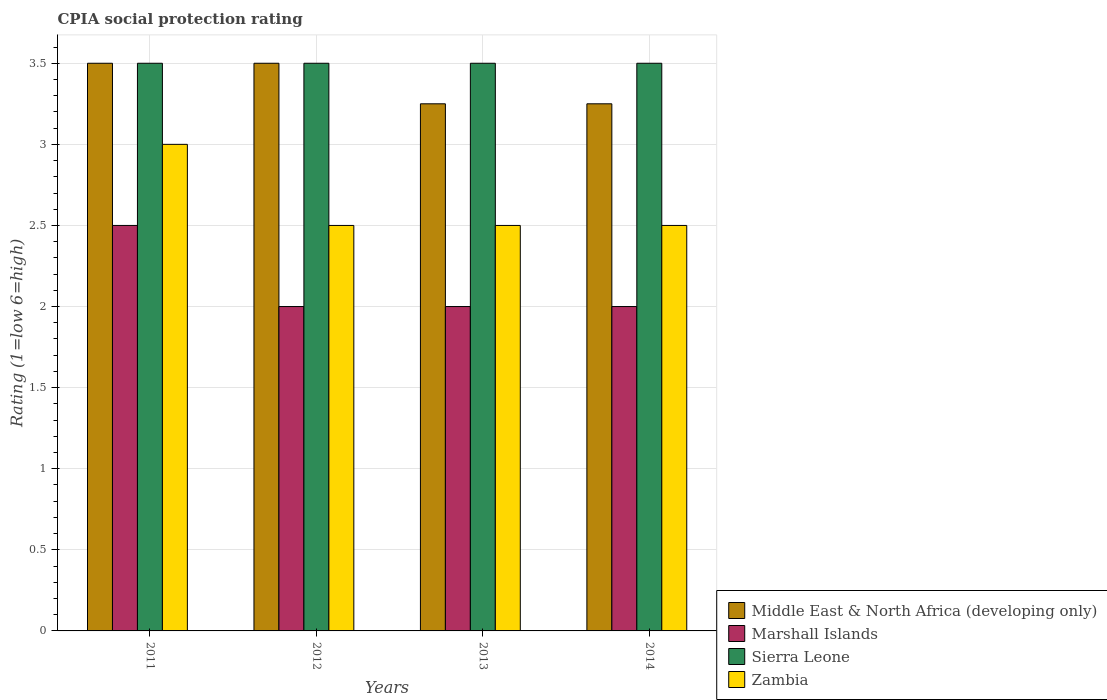How many different coloured bars are there?
Ensure brevity in your answer.  4. Are the number of bars per tick equal to the number of legend labels?
Ensure brevity in your answer.  Yes. How many bars are there on the 2nd tick from the left?
Your answer should be very brief. 4. What is the label of the 1st group of bars from the left?
Make the answer very short. 2011. In how many cases, is the number of bars for a given year not equal to the number of legend labels?
Offer a terse response. 0. Across all years, what is the minimum CPIA rating in Sierra Leone?
Offer a terse response. 3.5. In which year was the CPIA rating in Middle East & North Africa (developing only) maximum?
Provide a succinct answer. 2011. In which year was the CPIA rating in Sierra Leone minimum?
Give a very brief answer. 2011. What is the difference between the CPIA rating in Zambia in 2011 and the CPIA rating in Middle East & North Africa (developing only) in 2012?
Offer a terse response. -0.5. What is the average CPIA rating in Zambia per year?
Your answer should be very brief. 2.62. What is the difference between the highest and the second highest CPIA rating in Marshall Islands?
Ensure brevity in your answer.  0.5. Is the sum of the CPIA rating in Middle East & North Africa (developing only) in 2012 and 2014 greater than the maximum CPIA rating in Marshall Islands across all years?
Give a very brief answer. Yes. Is it the case that in every year, the sum of the CPIA rating in Middle East & North Africa (developing only) and CPIA rating in Zambia is greater than the sum of CPIA rating in Marshall Islands and CPIA rating in Sierra Leone?
Keep it short and to the point. Yes. What does the 3rd bar from the left in 2012 represents?
Keep it short and to the point. Sierra Leone. What does the 3rd bar from the right in 2014 represents?
Offer a terse response. Marshall Islands. Is it the case that in every year, the sum of the CPIA rating in Sierra Leone and CPIA rating in Marshall Islands is greater than the CPIA rating in Zambia?
Ensure brevity in your answer.  Yes. Are all the bars in the graph horizontal?
Your response must be concise. No. Are the values on the major ticks of Y-axis written in scientific E-notation?
Offer a terse response. No. Does the graph contain any zero values?
Ensure brevity in your answer.  No. Where does the legend appear in the graph?
Offer a terse response. Bottom right. How are the legend labels stacked?
Offer a terse response. Vertical. What is the title of the graph?
Give a very brief answer. CPIA social protection rating. What is the label or title of the Y-axis?
Make the answer very short. Rating (1=low 6=high). What is the Rating (1=low 6=high) in Middle East & North Africa (developing only) in 2011?
Make the answer very short. 3.5. What is the Rating (1=low 6=high) of Zambia in 2011?
Offer a very short reply. 3. What is the Rating (1=low 6=high) of Middle East & North Africa (developing only) in 2012?
Give a very brief answer. 3.5. What is the Rating (1=low 6=high) of Marshall Islands in 2012?
Ensure brevity in your answer.  2. What is the Rating (1=low 6=high) in Middle East & North Africa (developing only) in 2013?
Your answer should be compact. 3.25. What is the Rating (1=low 6=high) of Zambia in 2013?
Ensure brevity in your answer.  2.5. What is the Rating (1=low 6=high) of Middle East & North Africa (developing only) in 2014?
Your answer should be compact. 3.25. What is the Rating (1=low 6=high) in Marshall Islands in 2014?
Ensure brevity in your answer.  2. What is the Rating (1=low 6=high) of Sierra Leone in 2014?
Give a very brief answer. 3.5. Across all years, what is the maximum Rating (1=low 6=high) in Middle East & North Africa (developing only)?
Make the answer very short. 3.5. Across all years, what is the maximum Rating (1=low 6=high) of Marshall Islands?
Provide a succinct answer. 2.5. Across all years, what is the maximum Rating (1=low 6=high) in Sierra Leone?
Your answer should be compact. 3.5. Across all years, what is the minimum Rating (1=low 6=high) of Sierra Leone?
Keep it short and to the point. 3.5. Across all years, what is the minimum Rating (1=low 6=high) of Zambia?
Your response must be concise. 2.5. What is the total Rating (1=low 6=high) of Marshall Islands in the graph?
Make the answer very short. 8.5. What is the total Rating (1=low 6=high) in Zambia in the graph?
Give a very brief answer. 10.5. What is the difference between the Rating (1=low 6=high) of Sierra Leone in 2011 and that in 2012?
Offer a terse response. 0. What is the difference between the Rating (1=low 6=high) in Zambia in 2011 and that in 2012?
Provide a succinct answer. 0.5. What is the difference between the Rating (1=low 6=high) of Sierra Leone in 2011 and that in 2013?
Provide a short and direct response. 0. What is the difference between the Rating (1=low 6=high) in Zambia in 2011 and that in 2013?
Keep it short and to the point. 0.5. What is the difference between the Rating (1=low 6=high) of Marshall Islands in 2011 and that in 2014?
Offer a terse response. 0.5. What is the difference between the Rating (1=low 6=high) of Sierra Leone in 2011 and that in 2014?
Offer a very short reply. 0. What is the difference between the Rating (1=low 6=high) in Zambia in 2011 and that in 2014?
Ensure brevity in your answer.  0.5. What is the difference between the Rating (1=low 6=high) of Middle East & North Africa (developing only) in 2012 and that in 2013?
Your response must be concise. 0.25. What is the difference between the Rating (1=low 6=high) in Marshall Islands in 2012 and that in 2013?
Ensure brevity in your answer.  0. What is the difference between the Rating (1=low 6=high) of Marshall Islands in 2012 and that in 2014?
Your answer should be compact. 0. What is the difference between the Rating (1=low 6=high) in Middle East & North Africa (developing only) in 2013 and that in 2014?
Provide a short and direct response. 0. What is the difference between the Rating (1=low 6=high) of Marshall Islands in 2013 and that in 2014?
Offer a very short reply. 0. What is the difference between the Rating (1=low 6=high) of Sierra Leone in 2013 and that in 2014?
Make the answer very short. 0. What is the difference between the Rating (1=low 6=high) in Middle East & North Africa (developing only) in 2011 and the Rating (1=low 6=high) in Zambia in 2012?
Keep it short and to the point. 1. What is the difference between the Rating (1=low 6=high) of Middle East & North Africa (developing only) in 2011 and the Rating (1=low 6=high) of Marshall Islands in 2013?
Keep it short and to the point. 1.5. What is the difference between the Rating (1=low 6=high) of Middle East & North Africa (developing only) in 2011 and the Rating (1=low 6=high) of Zambia in 2013?
Ensure brevity in your answer.  1. What is the difference between the Rating (1=low 6=high) of Marshall Islands in 2011 and the Rating (1=low 6=high) of Zambia in 2013?
Ensure brevity in your answer.  0. What is the difference between the Rating (1=low 6=high) in Sierra Leone in 2011 and the Rating (1=low 6=high) in Zambia in 2013?
Keep it short and to the point. 1. What is the difference between the Rating (1=low 6=high) of Middle East & North Africa (developing only) in 2011 and the Rating (1=low 6=high) of Marshall Islands in 2014?
Offer a very short reply. 1.5. What is the difference between the Rating (1=low 6=high) in Middle East & North Africa (developing only) in 2011 and the Rating (1=low 6=high) in Zambia in 2014?
Your answer should be compact. 1. What is the difference between the Rating (1=low 6=high) in Marshall Islands in 2012 and the Rating (1=low 6=high) in Zambia in 2013?
Provide a short and direct response. -0.5. What is the difference between the Rating (1=low 6=high) in Marshall Islands in 2012 and the Rating (1=low 6=high) in Sierra Leone in 2014?
Give a very brief answer. -1.5. What is the difference between the Rating (1=low 6=high) of Middle East & North Africa (developing only) in 2013 and the Rating (1=low 6=high) of Marshall Islands in 2014?
Provide a succinct answer. 1.25. What is the difference between the Rating (1=low 6=high) of Middle East & North Africa (developing only) in 2013 and the Rating (1=low 6=high) of Sierra Leone in 2014?
Your response must be concise. -0.25. What is the difference between the Rating (1=low 6=high) of Marshall Islands in 2013 and the Rating (1=low 6=high) of Zambia in 2014?
Your answer should be very brief. -0.5. What is the difference between the Rating (1=low 6=high) in Sierra Leone in 2013 and the Rating (1=low 6=high) in Zambia in 2014?
Your answer should be very brief. 1. What is the average Rating (1=low 6=high) of Middle East & North Africa (developing only) per year?
Make the answer very short. 3.38. What is the average Rating (1=low 6=high) of Marshall Islands per year?
Offer a terse response. 2.12. What is the average Rating (1=low 6=high) of Zambia per year?
Provide a short and direct response. 2.62. In the year 2011, what is the difference between the Rating (1=low 6=high) in Middle East & North Africa (developing only) and Rating (1=low 6=high) in Zambia?
Make the answer very short. 0.5. In the year 2011, what is the difference between the Rating (1=low 6=high) of Sierra Leone and Rating (1=low 6=high) of Zambia?
Provide a short and direct response. 0.5. In the year 2013, what is the difference between the Rating (1=low 6=high) in Middle East & North Africa (developing only) and Rating (1=low 6=high) in Sierra Leone?
Your answer should be very brief. -0.25. In the year 2013, what is the difference between the Rating (1=low 6=high) of Marshall Islands and Rating (1=low 6=high) of Sierra Leone?
Make the answer very short. -1.5. In the year 2013, what is the difference between the Rating (1=low 6=high) in Sierra Leone and Rating (1=low 6=high) in Zambia?
Offer a very short reply. 1. In the year 2014, what is the difference between the Rating (1=low 6=high) in Middle East & North Africa (developing only) and Rating (1=low 6=high) in Sierra Leone?
Your answer should be compact. -0.25. In the year 2014, what is the difference between the Rating (1=low 6=high) in Middle East & North Africa (developing only) and Rating (1=low 6=high) in Zambia?
Your answer should be very brief. 0.75. In the year 2014, what is the difference between the Rating (1=low 6=high) of Sierra Leone and Rating (1=low 6=high) of Zambia?
Offer a terse response. 1. What is the ratio of the Rating (1=low 6=high) in Middle East & North Africa (developing only) in 2011 to that in 2013?
Your response must be concise. 1.08. What is the ratio of the Rating (1=low 6=high) of Marshall Islands in 2011 to that in 2013?
Your response must be concise. 1.25. What is the ratio of the Rating (1=low 6=high) of Zambia in 2011 to that in 2013?
Your answer should be very brief. 1.2. What is the ratio of the Rating (1=low 6=high) of Middle East & North Africa (developing only) in 2011 to that in 2014?
Your response must be concise. 1.08. What is the ratio of the Rating (1=low 6=high) of Middle East & North Africa (developing only) in 2012 to that in 2013?
Provide a short and direct response. 1.08. What is the ratio of the Rating (1=low 6=high) of Marshall Islands in 2012 to that in 2013?
Provide a short and direct response. 1. What is the ratio of the Rating (1=low 6=high) of Middle East & North Africa (developing only) in 2012 to that in 2014?
Make the answer very short. 1.08. What is the ratio of the Rating (1=low 6=high) of Sierra Leone in 2012 to that in 2014?
Ensure brevity in your answer.  1. What is the ratio of the Rating (1=low 6=high) in Zambia in 2012 to that in 2014?
Your answer should be very brief. 1. What is the ratio of the Rating (1=low 6=high) of Middle East & North Africa (developing only) in 2013 to that in 2014?
Offer a terse response. 1. What is the ratio of the Rating (1=low 6=high) of Marshall Islands in 2013 to that in 2014?
Make the answer very short. 1. What is the ratio of the Rating (1=low 6=high) in Zambia in 2013 to that in 2014?
Offer a very short reply. 1. What is the difference between the highest and the second highest Rating (1=low 6=high) in Middle East & North Africa (developing only)?
Your response must be concise. 0. What is the difference between the highest and the lowest Rating (1=low 6=high) of Marshall Islands?
Provide a short and direct response. 0.5. 